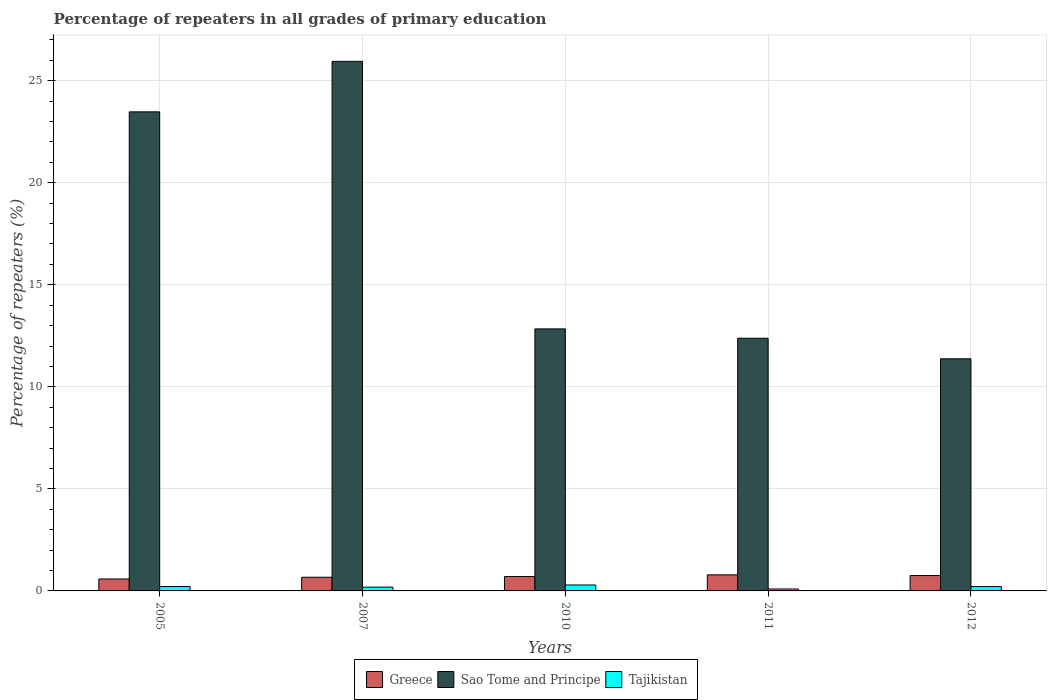Are the number of bars per tick equal to the number of legend labels?
Offer a terse response. Yes. Are the number of bars on each tick of the X-axis equal?
Make the answer very short. Yes. How many bars are there on the 1st tick from the left?
Ensure brevity in your answer.  3. How many bars are there on the 1st tick from the right?
Ensure brevity in your answer.  3. In how many cases, is the number of bars for a given year not equal to the number of legend labels?
Ensure brevity in your answer.  0. What is the percentage of repeaters in Sao Tome and Principe in 2005?
Provide a short and direct response. 23.47. Across all years, what is the maximum percentage of repeaters in Tajikistan?
Ensure brevity in your answer.  0.29. Across all years, what is the minimum percentage of repeaters in Tajikistan?
Make the answer very short. 0.09. In which year was the percentage of repeaters in Greece maximum?
Your answer should be very brief. 2011. In which year was the percentage of repeaters in Greece minimum?
Give a very brief answer. 2005. What is the total percentage of repeaters in Sao Tome and Principe in the graph?
Ensure brevity in your answer.  86.01. What is the difference between the percentage of repeaters in Sao Tome and Principe in 2005 and that in 2010?
Your answer should be compact. 10.64. What is the difference between the percentage of repeaters in Sao Tome and Principe in 2010 and the percentage of repeaters in Tajikistan in 2012?
Give a very brief answer. 12.63. What is the average percentage of repeaters in Greece per year?
Your answer should be very brief. 0.7. In the year 2007, what is the difference between the percentage of repeaters in Sao Tome and Principe and percentage of repeaters in Tajikistan?
Make the answer very short. 25.76. What is the ratio of the percentage of repeaters in Greece in 2011 to that in 2012?
Provide a succinct answer. 1.05. Is the difference between the percentage of repeaters in Sao Tome and Principe in 2007 and 2010 greater than the difference between the percentage of repeaters in Tajikistan in 2007 and 2010?
Keep it short and to the point. Yes. What is the difference between the highest and the second highest percentage of repeaters in Sao Tome and Principe?
Provide a short and direct response. 2.47. What is the difference between the highest and the lowest percentage of repeaters in Sao Tome and Principe?
Give a very brief answer. 14.57. In how many years, is the percentage of repeaters in Tajikistan greater than the average percentage of repeaters in Tajikistan taken over all years?
Provide a short and direct response. 3. Is the sum of the percentage of repeaters in Sao Tome and Principe in 2005 and 2012 greater than the maximum percentage of repeaters in Greece across all years?
Offer a very short reply. Yes. What does the 3rd bar from the left in 2010 represents?
Give a very brief answer. Tajikistan. What does the 2nd bar from the right in 2012 represents?
Offer a terse response. Sao Tome and Principe. Is it the case that in every year, the sum of the percentage of repeaters in Tajikistan and percentage of repeaters in Greece is greater than the percentage of repeaters in Sao Tome and Principe?
Give a very brief answer. No. How many bars are there?
Your response must be concise. 15. What is the difference between two consecutive major ticks on the Y-axis?
Your response must be concise. 5. Does the graph contain any zero values?
Offer a terse response. No. Where does the legend appear in the graph?
Provide a succinct answer. Bottom center. How many legend labels are there?
Make the answer very short. 3. How are the legend labels stacked?
Your answer should be very brief. Horizontal. What is the title of the graph?
Provide a succinct answer. Percentage of repeaters in all grades of primary education. What is the label or title of the Y-axis?
Your response must be concise. Percentage of repeaters (%). What is the Percentage of repeaters (%) of Greece in 2005?
Give a very brief answer. 0.59. What is the Percentage of repeaters (%) of Sao Tome and Principe in 2005?
Your answer should be compact. 23.47. What is the Percentage of repeaters (%) in Tajikistan in 2005?
Your response must be concise. 0.21. What is the Percentage of repeaters (%) of Greece in 2007?
Your response must be concise. 0.67. What is the Percentage of repeaters (%) of Sao Tome and Principe in 2007?
Your response must be concise. 25.95. What is the Percentage of repeaters (%) of Tajikistan in 2007?
Give a very brief answer. 0.18. What is the Percentage of repeaters (%) of Greece in 2010?
Your response must be concise. 0.7. What is the Percentage of repeaters (%) in Sao Tome and Principe in 2010?
Provide a succinct answer. 12.84. What is the Percentage of repeaters (%) of Tajikistan in 2010?
Provide a short and direct response. 0.29. What is the Percentage of repeaters (%) of Greece in 2011?
Ensure brevity in your answer.  0.79. What is the Percentage of repeaters (%) in Sao Tome and Principe in 2011?
Your answer should be compact. 12.38. What is the Percentage of repeaters (%) of Tajikistan in 2011?
Make the answer very short. 0.09. What is the Percentage of repeaters (%) in Greece in 2012?
Your response must be concise. 0.75. What is the Percentage of repeaters (%) of Sao Tome and Principe in 2012?
Provide a succinct answer. 11.37. What is the Percentage of repeaters (%) of Tajikistan in 2012?
Make the answer very short. 0.21. Across all years, what is the maximum Percentage of repeaters (%) in Greece?
Your answer should be compact. 0.79. Across all years, what is the maximum Percentage of repeaters (%) in Sao Tome and Principe?
Provide a succinct answer. 25.95. Across all years, what is the maximum Percentage of repeaters (%) in Tajikistan?
Ensure brevity in your answer.  0.29. Across all years, what is the minimum Percentage of repeaters (%) in Greece?
Provide a short and direct response. 0.59. Across all years, what is the minimum Percentage of repeaters (%) of Sao Tome and Principe?
Provide a succinct answer. 11.37. Across all years, what is the minimum Percentage of repeaters (%) of Tajikistan?
Ensure brevity in your answer.  0.09. What is the total Percentage of repeaters (%) of Greece in the graph?
Your answer should be compact. 3.5. What is the total Percentage of repeaters (%) of Sao Tome and Principe in the graph?
Your answer should be compact. 86.01. What is the difference between the Percentage of repeaters (%) of Greece in 2005 and that in 2007?
Make the answer very short. -0.09. What is the difference between the Percentage of repeaters (%) in Sao Tome and Principe in 2005 and that in 2007?
Provide a succinct answer. -2.47. What is the difference between the Percentage of repeaters (%) of Tajikistan in 2005 and that in 2007?
Offer a terse response. 0.03. What is the difference between the Percentage of repeaters (%) of Greece in 2005 and that in 2010?
Ensure brevity in your answer.  -0.12. What is the difference between the Percentage of repeaters (%) in Sao Tome and Principe in 2005 and that in 2010?
Your answer should be very brief. 10.64. What is the difference between the Percentage of repeaters (%) of Tajikistan in 2005 and that in 2010?
Provide a succinct answer. -0.08. What is the difference between the Percentage of repeaters (%) of Greece in 2005 and that in 2011?
Provide a short and direct response. -0.2. What is the difference between the Percentage of repeaters (%) of Sao Tome and Principe in 2005 and that in 2011?
Provide a succinct answer. 11.09. What is the difference between the Percentage of repeaters (%) in Tajikistan in 2005 and that in 2011?
Keep it short and to the point. 0.12. What is the difference between the Percentage of repeaters (%) of Greece in 2005 and that in 2012?
Make the answer very short. -0.17. What is the difference between the Percentage of repeaters (%) of Sao Tome and Principe in 2005 and that in 2012?
Ensure brevity in your answer.  12.1. What is the difference between the Percentage of repeaters (%) of Tajikistan in 2005 and that in 2012?
Your response must be concise. 0. What is the difference between the Percentage of repeaters (%) of Greece in 2007 and that in 2010?
Offer a very short reply. -0.03. What is the difference between the Percentage of repeaters (%) in Sao Tome and Principe in 2007 and that in 2010?
Keep it short and to the point. 13.11. What is the difference between the Percentage of repeaters (%) of Tajikistan in 2007 and that in 2010?
Your answer should be very brief. -0.11. What is the difference between the Percentage of repeaters (%) of Greece in 2007 and that in 2011?
Give a very brief answer. -0.12. What is the difference between the Percentage of repeaters (%) of Sao Tome and Principe in 2007 and that in 2011?
Provide a short and direct response. 13.57. What is the difference between the Percentage of repeaters (%) in Tajikistan in 2007 and that in 2011?
Offer a terse response. 0.09. What is the difference between the Percentage of repeaters (%) of Greece in 2007 and that in 2012?
Give a very brief answer. -0.08. What is the difference between the Percentage of repeaters (%) of Sao Tome and Principe in 2007 and that in 2012?
Provide a short and direct response. 14.57. What is the difference between the Percentage of repeaters (%) in Tajikistan in 2007 and that in 2012?
Offer a very short reply. -0.03. What is the difference between the Percentage of repeaters (%) of Greece in 2010 and that in 2011?
Provide a succinct answer. -0.08. What is the difference between the Percentage of repeaters (%) in Sao Tome and Principe in 2010 and that in 2011?
Give a very brief answer. 0.46. What is the difference between the Percentage of repeaters (%) in Tajikistan in 2010 and that in 2011?
Your answer should be very brief. 0.2. What is the difference between the Percentage of repeaters (%) of Greece in 2010 and that in 2012?
Ensure brevity in your answer.  -0.05. What is the difference between the Percentage of repeaters (%) in Sao Tome and Principe in 2010 and that in 2012?
Your answer should be compact. 1.46. What is the difference between the Percentage of repeaters (%) in Tajikistan in 2010 and that in 2012?
Offer a terse response. 0.08. What is the difference between the Percentage of repeaters (%) in Greece in 2011 and that in 2012?
Ensure brevity in your answer.  0.03. What is the difference between the Percentage of repeaters (%) in Tajikistan in 2011 and that in 2012?
Ensure brevity in your answer.  -0.12. What is the difference between the Percentage of repeaters (%) of Greece in 2005 and the Percentage of repeaters (%) of Sao Tome and Principe in 2007?
Your answer should be very brief. -25.36. What is the difference between the Percentage of repeaters (%) of Greece in 2005 and the Percentage of repeaters (%) of Tajikistan in 2007?
Keep it short and to the point. 0.4. What is the difference between the Percentage of repeaters (%) of Sao Tome and Principe in 2005 and the Percentage of repeaters (%) of Tajikistan in 2007?
Give a very brief answer. 23.29. What is the difference between the Percentage of repeaters (%) of Greece in 2005 and the Percentage of repeaters (%) of Sao Tome and Principe in 2010?
Offer a very short reply. -12.25. What is the difference between the Percentage of repeaters (%) of Greece in 2005 and the Percentage of repeaters (%) of Tajikistan in 2010?
Your answer should be very brief. 0.29. What is the difference between the Percentage of repeaters (%) of Sao Tome and Principe in 2005 and the Percentage of repeaters (%) of Tajikistan in 2010?
Offer a very short reply. 23.18. What is the difference between the Percentage of repeaters (%) in Greece in 2005 and the Percentage of repeaters (%) in Sao Tome and Principe in 2011?
Your answer should be compact. -11.8. What is the difference between the Percentage of repeaters (%) of Greece in 2005 and the Percentage of repeaters (%) of Tajikistan in 2011?
Provide a succinct answer. 0.49. What is the difference between the Percentage of repeaters (%) in Sao Tome and Principe in 2005 and the Percentage of repeaters (%) in Tajikistan in 2011?
Give a very brief answer. 23.38. What is the difference between the Percentage of repeaters (%) of Greece in 2005 and the Percentage of repeaters (%) of Sao Tome and Principe in 2012?
Make the answer very short. -10.79. What is the difference between the Percentage of repeaters (%) of Greece in 2005 and the Percentage of repeaters (%) of Tajikistan in 2012?
Offer a terse response. 0.37. What is the difference between the Percentage of repeaters (%) of Sao Tome and Principe in 2005 and the Percentage of repeaters (%) of Tajikistan in 2012?
Provide a succinct answer. 23.26. What is the difference between the Percentage of repeaters (%) in Greece in 2007 and the Percentage of repeaters (%) in Sao Tome and Principe in 2010?
Your answer should be compact. -12.17. What is the difference between the Percentage of repeaters (%) in Greece in 2007 and the Percentage of repeaters (%) in Tajikistan in 2010?
Offer a very short reply. 0.38. What is the difference between the Percentage of repeaters (%) of Sao Tome and Principe in 2007 and the Percentage of repeaters (%) of Tajikistan in 2010?
Your response must be concise. 25.66. What is the difference between the Percentage of repeaters (%) in Greece in 2007 and the Percentage of repeaters (%) in Sao Tome and Principe in 2011?
Make the answer very short. -11.71. What is the difference between the Percentage of repeaters (%) in Greece in 2007 and the Percentage of repeaters (%) in Tajikistan in 2011?
Your answer should be compact. 0.58. What is the difference between the Percentage of repeaters (%) of Sao Tome and Principe in 2007 and the Percentage of repeaters (%) of Tajikistan in 2011?
Your answer should be compact. 25.85. What is the difference between the Percentage of repeaters (%) of Greece in 2007 and the Percentage of repeaters (%) of Sao Tome and Principe in 2012?
Offer a very short reply. -10.7. What is the difference between the Percentage of repeaters (%) in Greece in 2007 and the Percentage of repeaters (%) in Tajikistan in 2012?
Make the answer very short. 0.46. What is the difference between the Percentage of repeaters (%) of Sao Tome and Principe in 2007 and the Percentage of repeaters (%) of Tajikistan in 2012?
Your answer should be very brief. 25.74. What is the difference between the Percentage of repeaters (%) of Greece in 2010 and the Percentage of repeaters (%) of Sao Tome and Principe in 2011?
Your answer should be compact. -11.68. What is the difference between the Percentage of repeaters (%) in Greece in 2010 and the Percentage of repeaters (%) in Tajikistan in 2011?
Your answer should be compact. 0.61. What is the difference between the Percentage of repeaters (%) of Sao Tome and Principe in 2010 and the Percentage of repeaters (%) of Tajikistan in 2011?
Your response must be concise. 12.74. What is the difference between the Percentage of repeaters (%) in Greece in 2010 and the Percentage of repeaters (%) in Sao Tome and Principe in 2012?
Keep it short and to the point. -10.67. What is the difference between the Percentage of repeaters (%) in Greece in 2010 and the Percentage of repeaters (%) in Tajikistan in 2012?
Give a very brief answer. 0.49. What is the difference between the Percentage of repeaters (%) of Sao Tome and Principe in 2010 and the Percentage of repeaters (%) of Tajikistan in 2012?
Provide a short and direct response. 12.63. What is the difference between the Percentage of repeaters (%) in Greece in 2011 and the Percentage of repeaters (%) in Sao Tome and Principe in 2012?
Offer a very short reply. -10.59. What is the difference between the Percentage of repeaters (%) in Greece in 2011 and the Percentage of repeaters (%) in Tajikistan in 2012?
Make the answer very short. 0.57. What is the difference between the Percentage of repeaters (%) of Sao Tome and Principe in 2011 and the Percentage of repeaters (%) of Tajikistan in 2012?
Offer a terse response. 12.17. What is the average Percentage of repeaters (%) of Greece per year?
Your answer should be very brief. 0.7. What is the average Percentage of repeaters (%) in Sao Tome and Principe per year?
Give a very brief answer. 17.2. What is the average Percentage of repeaters (%) in Tajikistan per year?
Give a very brief answer. 0.2. In the year 2005, what is the difference between the Percentage of repeaters (%) of Greece and Percentage of repeaters (%) of Sao Tome and Principe?
Offer a terse response. -22.89. In the year 2005, what is the difference between the Percentage of repeaters (%) of Greece and Percentage of repeaters (%) of Tajikistan?
Your answer should be compact. 0.37. In the year 2005, what is the difference between the Percentage of repeaters (%) of Sao Tome and Principe and Percentage of repeaters (%) of Tajikistan?
Ensure brevity in your answer.  23.26. In the year 2007, what is the difference between the Percentage of repeaters (%) in Greece and Percentage of repeaters (%) in Sao Tome and Principe?
Offer a very short reply. -25.28. In the year 2007, what is the difference between the Percentage of repeaters (%) in Greece and Percentage of repeaters (%) in Tajikistan?
Your answer should be compact. 0.49. In the year 2007, what is the difference between the Percentage of repeaters (%) of Sao Tome and Principe and Percentage of repeaters (%) of Tajikistan?
Keep it short and to the point. 25.76. In the year 2010, what is the difference between the Percentage of repeaters (%) of Greece and Percentage of repeaters (%) of Sao Tome and Principe?
Give a very brief answer. -12.13. In the year 2010, what is the difference between the Percentage of repeaters (%) of Greece and Percentage of repeaters (%) of Tajikistan?
Your answer should be very brief. 0.41. In the year 2010, what is the difference between the Percentage of repeaters (%) of Sao Tome and Principe and Percentage of repeaters (%) of Tajikistan?
Your answer should be very brief. 12.55. In the year 2011, what is the difference between the Percentage of repeaters (%) in Greece and Percentage of repeaters (%) in Sao Tome and Principe?
Your answer should be very brief. -11.59. In the year 2011, what is the difference between the Percentage of repeaters (%) in Greece and Percentage of repeaters (%) in Tajikistan?
Make the answer very short. 0.69. In the year 2011, what is the difference between the Percentage of repeaters (%) in Sao Tome and Principe and Percentage of repeaters (%) in Tajikistan?
Provide a short and direct response. 12.29. In the year 2012, what is the difference between the Percentage of repeaters (%) of Greece and Percentage of repeaters (%) of Sao Tome and Principe?
Your response must be concise. -10.62. In the year 2012, what is the difference between the Percentage of repeaters (%) of Greece and Percentage of repeaters (%) of Tajikistan?
Offer a terse response. 0.54. In the year 2012, what is the difference between the Percentage of repeaters (%) in Sao Tome and Principe and Percentage of repeaters (%) in Tajikistan?
Your answer should be compact. 11.16. What is the ratio of the Percentage of repeaters (%) in Greece in 2005 to that in 2007?
Provide a succinct answer. 0.87. What is the ratio of the Percentage of repeaters (%) in Sao Tome and Principe in 2005 to that in 2007?
Your answer should be compact. 0.9. What is the ratio of the Percentage of repeaters (%) in Tajikistan in 2005 to that in 2007?
Your answer should be compact. 1.17. What is the ratio of the Percentage of repeaters (%) of Greece in 2005 to that in 2010?
Ensure brevity in your answer.  0.83. What is the ratio of the Percentage of repeaters (%) of Sao Tome and Principe in 2005 to that in 2010?
Ensure brevity in your answer.  1.83. What is the ratio of the Percentage of repeaters (%) in Tajikistan in 2005 to that in 2010?
Give a very brief answer. 0.74. What is the ratio of the Percentage of repeaters (%) in Greece in 2005 to that in 2011?
Ensure brevity in your answer.  0.74. What is the ratio of the Percentage of repeaters (%) of Sao Tome and Principe in 2005 to that in 2011?
Provide a short and direct response. 1.9. What is the ratio of the Percentage of repeaters (%) in Tajikistan in 2005 to that in 2011?
Offer a terse response. 2.27. What is the ratio of the Percentage of repeaters (%) in Greece in 2005 to that in 2012?
Give a very brief answer. 0.78. What is the ratio of the Percentage of repeaters (%) of Sao Tome and Principe in 2005 to that in 2012?
Offer a very short reply. 2.06. What is the ratio of the Percentage of repeaters (%) of Tajikistan in 2005 to that in 2012?
Offer a terse response. 1.01. What is the ratio of the Percentage of repeaters (%) in Greece in 2007 to that in 2010?
Your answer should be very brief. 0.95. What is the ratio of the Percentage of repeaters (%) of Sao Tome and Principe in 2007 to that in 2010?
Provide a short and direct response. 2.02. What is the ratio of the Percentage of repeaters (%) in Tajikistan in 2007 to that in 2010?
Your answer should be very brief. 0.63. What is the ratio of the Percentage of repeaters (%) in Greece in 2007 to that in 2011?
Provide a short and direct response. 0.85. What is the ratio of the Percentage of repeaters (%) in Sao Tome and Principe in 2007 to that in 2011?
Your response must be concise. 2.1. What is the ratio of the Percentage of repeaters (%) of Tajikistan in 2007 to that in 2011?
Your answer should be very brief. 1.95. What is the ratio of the Percentage of repeaters (%) in Greece in 2007 to that in 2012?
Keep it short and to the point. 0.89. What is the ratio of the Percentage of repeaters (%) in Sao Tome and Principe in 2007 to that in 2012?
Give a very brief answer. 2.28. What is the ratio of the Percentage of repeaters (%) in Tajikistan in 2007 to that in 2012?
Your response must be concise. 0.87. What is the ratio of the Percentage of repeaters (%) of Greece in 2010 to that in 2011?
Provide a short and direct response. 0.9. What is the ratio of the Percentage of repeaters (%) of Tajikistan in 2010 to that in 2011?
Your answer should be compact. 3.09. What is the ratio of the Percentage of repeaters (%) of Greece in 2010 to that in 2012?
Make the answer very short. 0.94. What is the ratio of the Percentage of repeaters (%) in Sao Tome and Principe in 2010 to that in 2012?
Give a very brief answer. 1.13. What is the ratio of the Percentage of repeaters (%) of Tajikistan in 2010 to that in 2012?
Offer a terse response. 1.37. What is the ratio of the Percentage of repeaters (%) of Greece in 2011 to that in 2012?
Keep it short and to the point. 1.05. What is the ratio of the Percentage of repeaters (%) of Sao Tome and Principe in 2011 to that in 2012?
Your response must be concise. 1.09. What is the ratio of the Percentage of repeaters (%) in Tajikistan in 2011 to that in 2012?
Make the answer very short. 0.44. What is the difference between the highest and the second highest Percentage of repeaters (%) in Greece?
Give a very brief answer. 0.03. What is the difference between the highest and the second highest Percentage of repeaters (%) in Sao Tome and Principe?
Offer a terse response. 2.47. What is the difference between the highest and the second highest Percentage of repeaters (%) of Tajikistan?
Offer a very short reply. 0.08. What is the difference between the highest and the lowest Percentage of repeaters (%) of Greece?
Your answer should be very brief. 0.2. What is the difference between the highest and the lowest Percentage of repeaters (%) of Sao Tome and Principe?
Your answer should be very brief. 14.57. What is the difference between the highest and the lowest Percentage of repeaters (%) in Tajikistan?
Give a very brief answer. 0.2. 